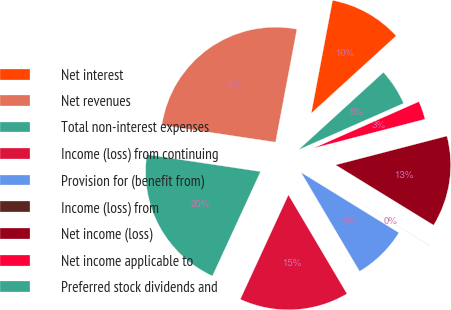Convert chart to OTSL. <chart><loc_0><loc_0><loc_500><loc_500><pie_chart><fcel>Net interest<fcel>Net revenues<fcel>Total non-interest expenses<fcel>Income (loss) from continuing<fcel>Provision for (benefit from)<fcel>Income (loss) from<fcel>Net income (loss)<fcel>Net income applicable to<fcel>Preferred stock dividends and<nl><fcel>10.26%<fcel>25.61%<fcel>20.49%<fcel>15.38%<fcel>7.7%<fcel>0.02%<fcel>12.82%<fcel>2.58%<fcel>5.14%<nl></chart> 